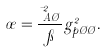Convert formula to latex. <formula><loc_0><loc_0><loc_500><loc_500>\sigma = \frac { \mu _ { A \chi } ^ { 2 } } { \pi } g _ { p \chi \chi } ^ { 2 } .</formula> 